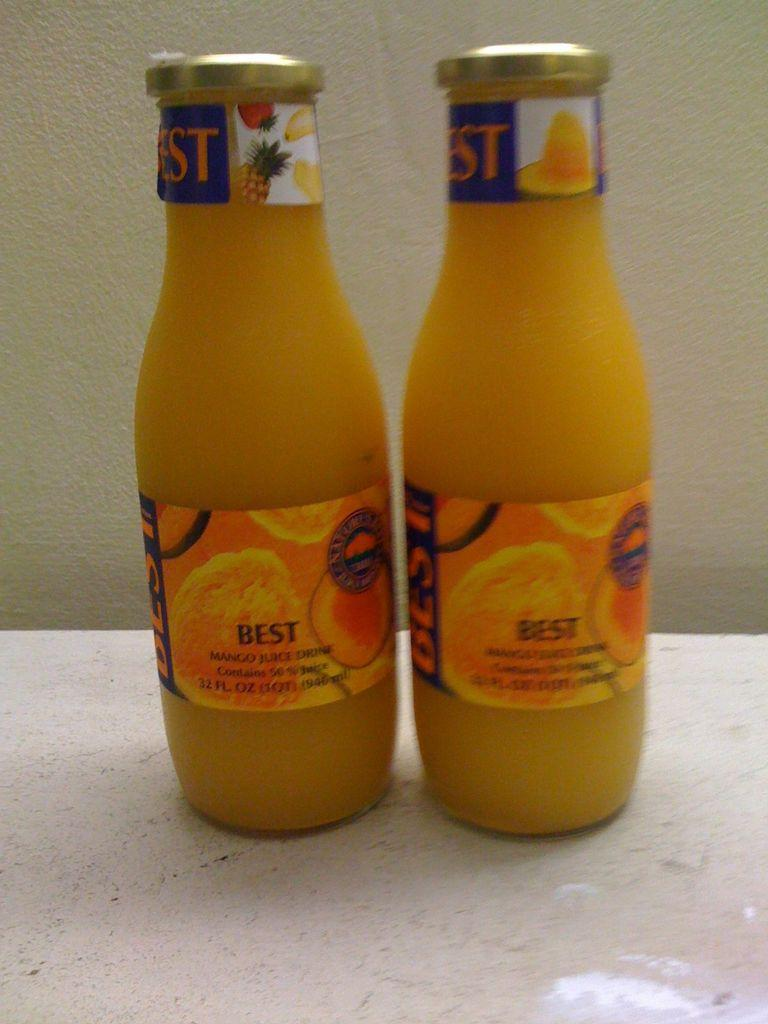<image>
Share a concise interpretation of the image provided. Two bottles of mango juice smoothie sit side by side. 